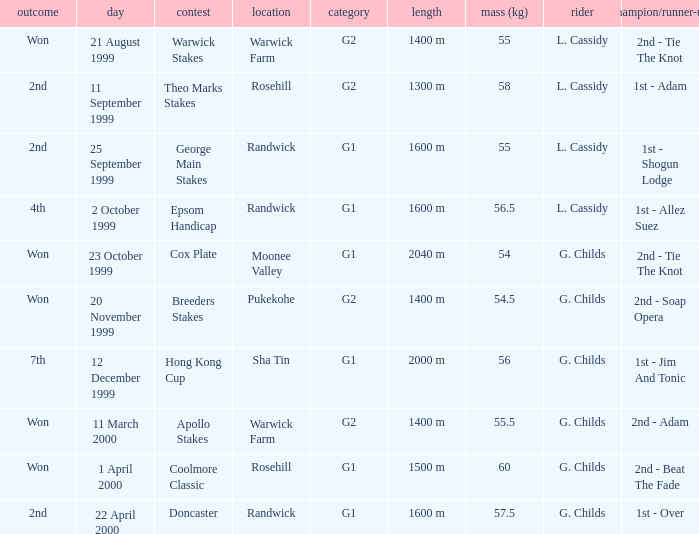List the weight for 56 kilograms. 2000 m. 